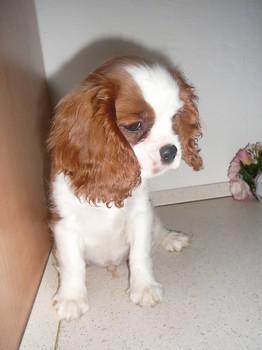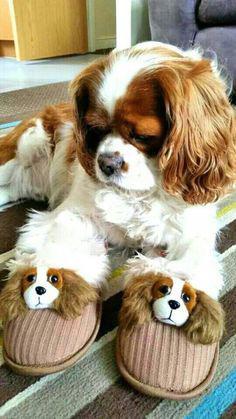The first image is the image on the left, the second image is the image on the right. Assess this claim about the two images: "There are three dogs, and one is looking straight at the camera.". Correct or not? Answer yes or no. No. 